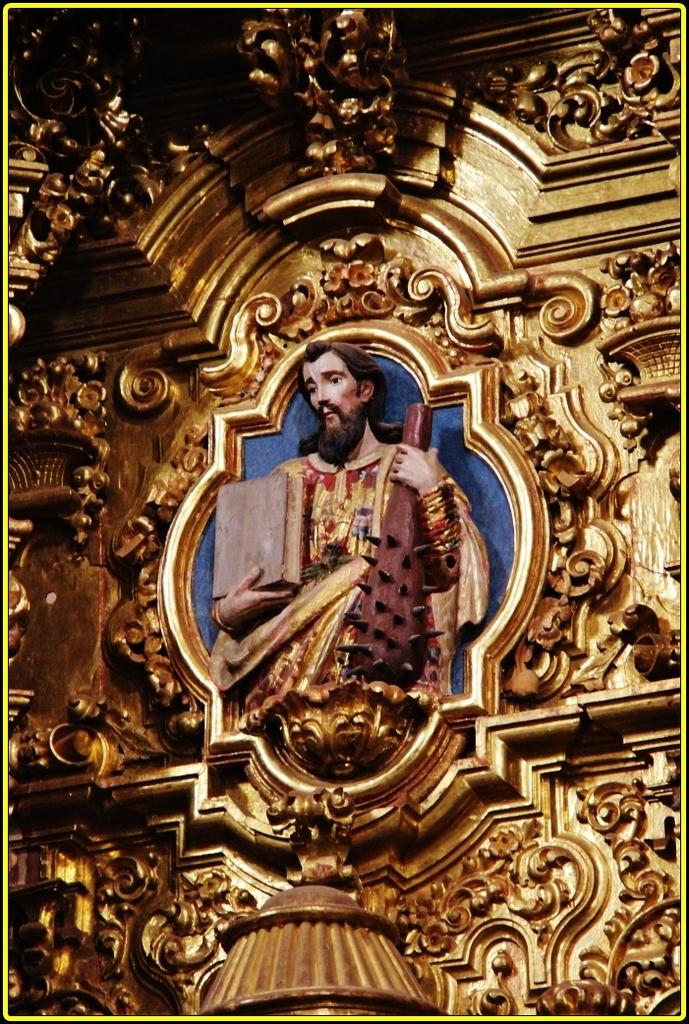What is depicted in the sculpture in the image? There is a sculpture of a man in the image. What is the man holding in the sculpture? The man is holding a book and a violin in the sculpture. What can be seen on the wall in the image? There is a design on the wall in the image. What type of needle is the man using to sew a leather jacket in the image? There is no needle or leather jacket present in the image; it features a sculpture of a man holding a book and a violin. 